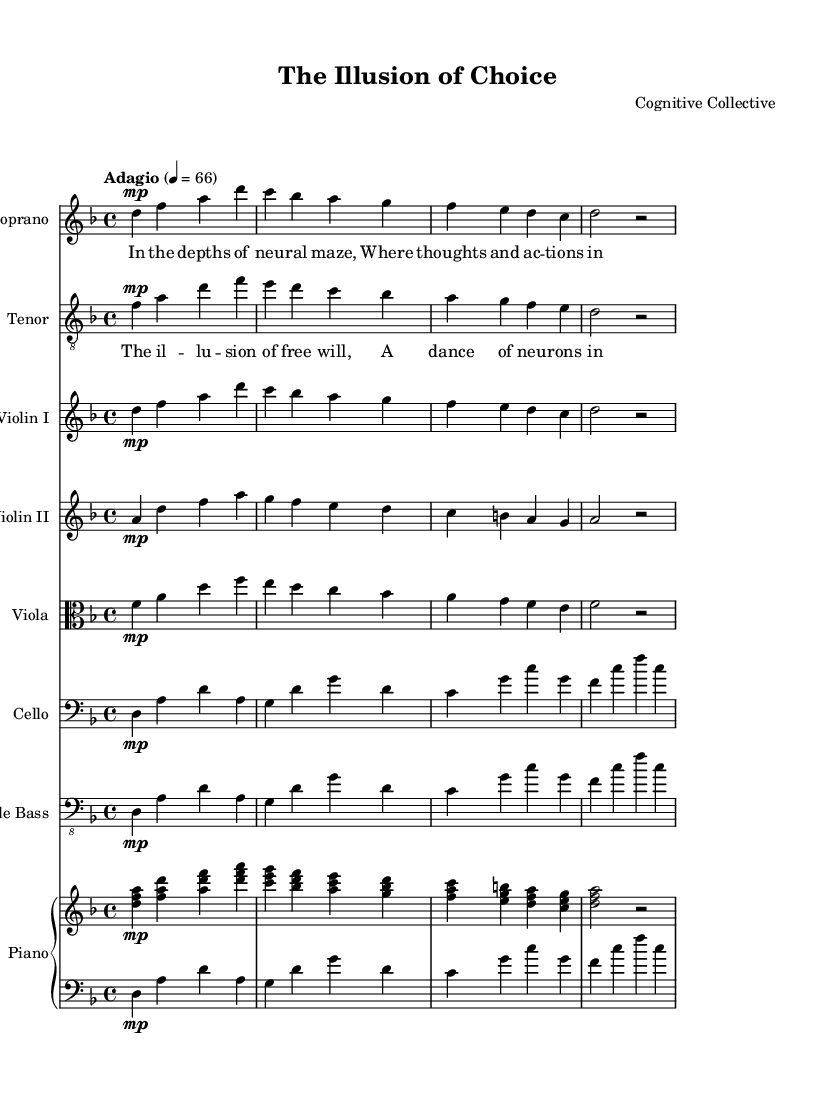What is the key signature of this music? The key signature shown is D minor, which has one flat (B flat). This is deduced from the "key d.", which indicates D is the tonic note and the presence of one flat is typical of D minor.
Answer: D minor What is the time signature of this music? The time signature is 4/4, as indicated by the "time 4/4" specified in the global settings. This means there are four beats in each measure, and the quarter note gets one beat.
Answer: 4/4 What is the tempo of the piece? The tempo marking indicates "Adagio" with a metronome marking of 4 = 66. "Adagio" suggests a slow tempo, and "4 = 66" indicates that there are 66 quarter note beats per minute.
Answer: Adagio, 4 = 66 How many vocal parts are there in this score? The score has two vocal parts as indicated by the presence of separate staves for Soprano and Tenor. They are clearly labeled and provide distinct melodic lines for each voice.
Answer: Two What theme does the chorus explore in the lyrics? The chorus lyrics contain the lines "The illusion of free will, A dance of neurons in our mind," suggesting a philosophical exploration of free will in relation to cognitive neuroscience. This reflects the overarching theme of consciousness as related to human agency.
Answer: Illusion of free will Which instruments form the string section in this opera? The string section comprises Violin I, Violin II, Viola, Cello, and Double Bass. Each of these is represented by a separate staff in the score, indicating their individual melodic and harmonic contributions to the piece.
Answer: Violin I, Violin II, Viola, Cello, Double Bass What is the primary mood conveyed by the piece based on the tempo and dynamics? The piece likely conveys a reflective or introspective mood, supported by the "Adagio" tempo and the use of "mp" (mezzo-piano) dynamics throughout the vocal and instrumental parts, suggesting a softer, contemplative sound.
Answer: Reflective 